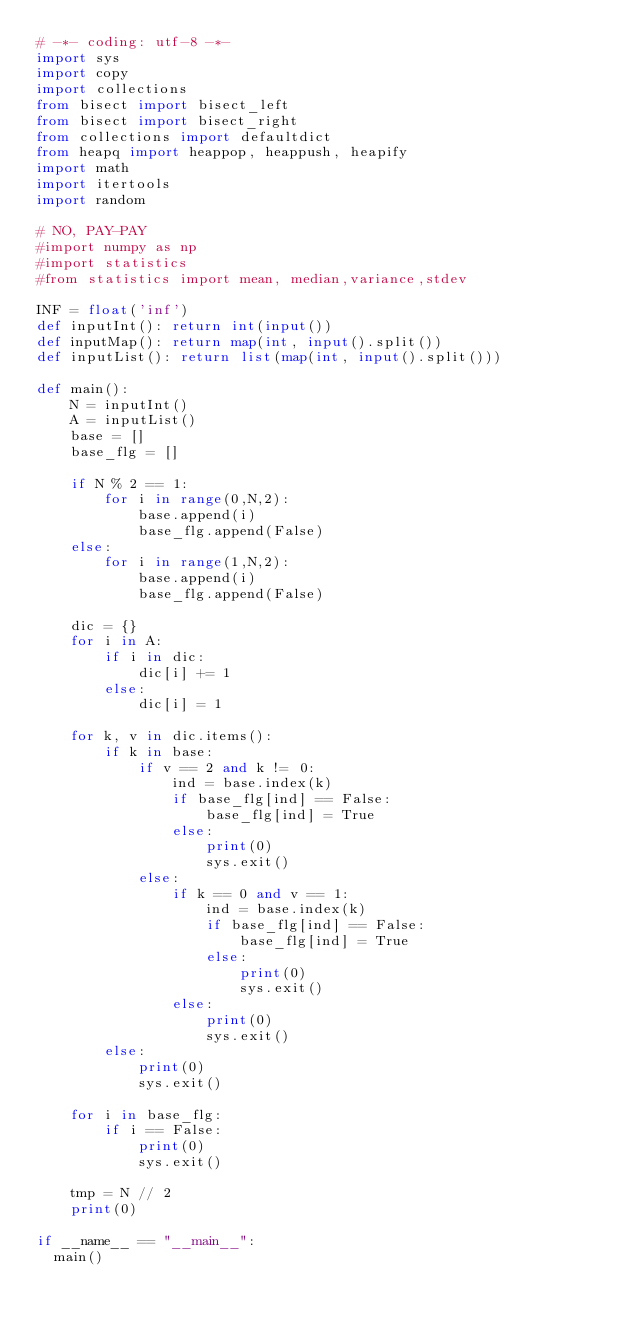Convert code to text. <code><loc_0><loc_0><loc_500><loc_500><_Python_># -*- coding: utf-8 -*-
import sys
import copy
import collections
from bisect import bisect_left
from bisect import bisect_right
from collections import defaultdict
from heapq import heappop, heappush, heapify
import math
import itertools
import random
 
# NO, PAY-PAY
#import numpy as np
#import statistics
#from statistics import mean, median,variance,stdev
 
INF = float('inf')
def inputInt(): return int(input())
def inputMap(): return map(int, input().split())
def inputList(): return list(map(int, input().split()))
 
def main():
    N = inputInt()
    A = inputList()
    base = []
    base_flg = []
    
    if N % 2 == 1:
        for i in range(0,N,2):
            base.append(i)
            base_flg.append(False)
    else:
        for i in range(1,N,2):
            base.append(i)
            base_flg.append(False)
            
    dic = {}
    for i in A:
        if i in dic:
            dic[i] += 1
        else:
            dic[i] = 1
            
    for k, v in dic.items():
        if k in base:
            if v == 2 and k != 0:
                ind = base.index(k)
                if base_flg[ind] == False:
                    base_flg[ind] = True
                else:
                    print(0)
                    sys.exit()
            else:
                if k == 0 and v == 1:
                    ind = base.index(k)
                    if base_flg[ind] == False:
                        base_flg[ind] = True
                    else:
                        print(0)
                        sys.exit()
                else:
                    print(0)
                    sys.exit()
        else:
            print(0)
            sys.exit()
            
    for i in base_flg:
        if i == False:
            print(0)
            sys.exit()
            
    tmp = N // 2    
    print(0)
    
if __name__ == "__main__":
	main()
</code> 